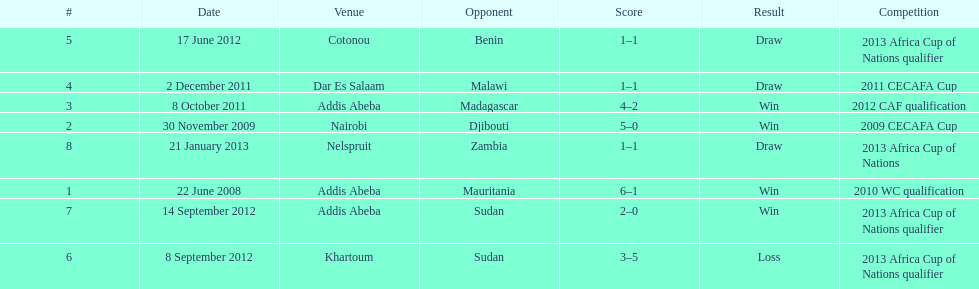How long in years down this table cover? 5. 